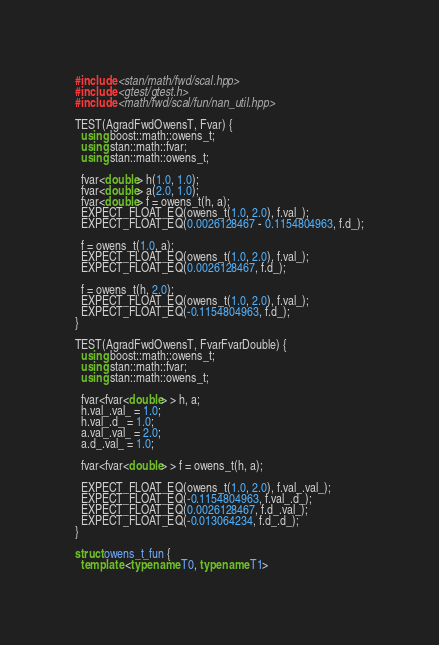Convert code to text. <code><loc_0><loc_0><loc_500><loc_500><_C++_>#include <stan/math/fwd/scal.hpp>
#include <gtest/gtest.h>
#include <math/fwd/scal/fun/nan_util.hpp>

TEST(AgradFwdOwensT, Fvar) {
  using boost::math::owens_t;
  using stan::math::fvar;
  using stan::math::owens_t;

  fvar<double> h(1.0, 1.0);
  fvar<double> a(2.0, 1.0);
  fvar<double> f = owens_t(h, a);
  EXPECT_FLOAT_EQ(owens_t(1.0, 2.0), f.val_);
  EXPECT_FLOAT_EQ(0.0026128467 - 0.1154804963, f.d_);

  f = owens_t(1.0, a);
  EXPECT_FLOAT_EQ(owens_t(1.0, 2.0), f.val_);
  EXPECT_FLOAT_EQ(0.0026128467, f.d_);

  f = owens_t(h, 2.0);
  EXPECT_FLOAT_EQ(owens_t(1.0, 2.0), f.val_);
  EXPECT_FLOAT_EQ(-0.1154804963, f.d_);
}

TEST(AgradFwdOwensT, FvarFvarDouble) {
  using boost::math::owens_t;
  using stan::math::fvar;
  using stan::math::owens_t;

  fvar<fvar<double> > h, a;
  h.val_.val_ = 1.0;
  h.val_.d_ = 1.0;
  a.val_.val_ = 2.0;
  a.d_.val_ = 1.0;

  fvar<fvar<double> > f = owens_t(h, a);

  EXPECT_FLOAT_EQ(owens_t(1.0, 2.0), f.val_.val_);
  EXPECT_FLOAT_EQ(-0.1154804963, f.val_.d_);
  EXPECT_FLOAT_EQ(0.0026128467, f.d_.val_);
  EXPECT_FLOAT_EQ(-0.013064234, f.d_.d_);
}

struct owens_t_fun {
  template <typename T0, typename T1></code> 